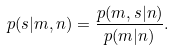Convert formula to latex. <formula><loc_0><loc_0><loc_500><loc_500>p ( { s | m , n } ) = \frac { p ( { m , s | n } ) } { p ( { m | n } ) } .</formula> 